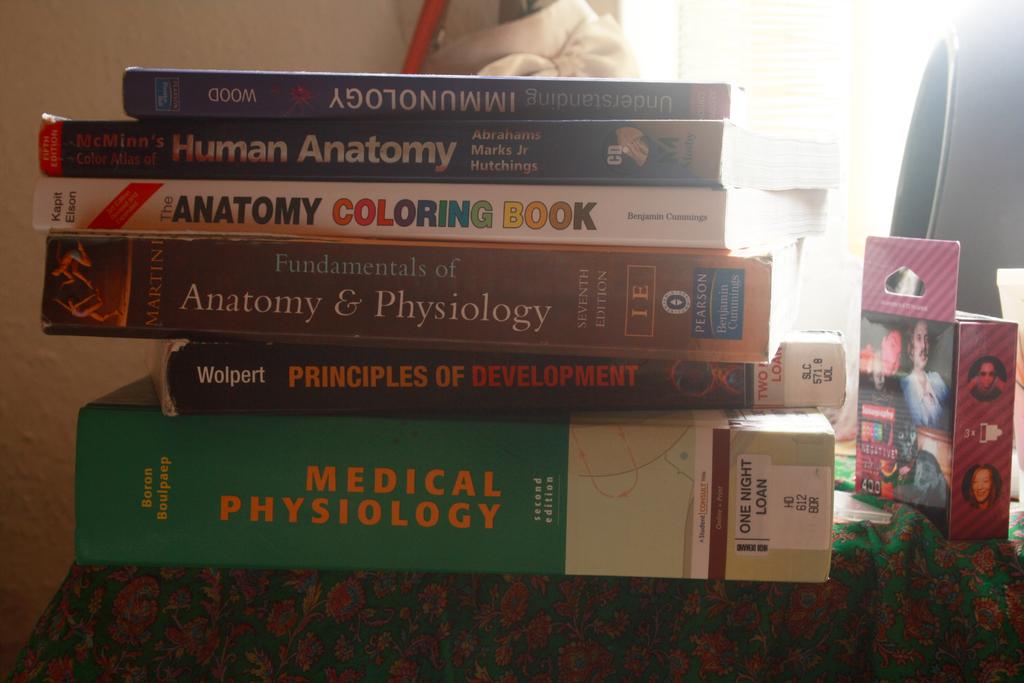What kind of coloring book is pictured?
Offer a terse response. Anatomy. What is the topic of the large green book?
Keep it short and to the point. Medical physiology. 